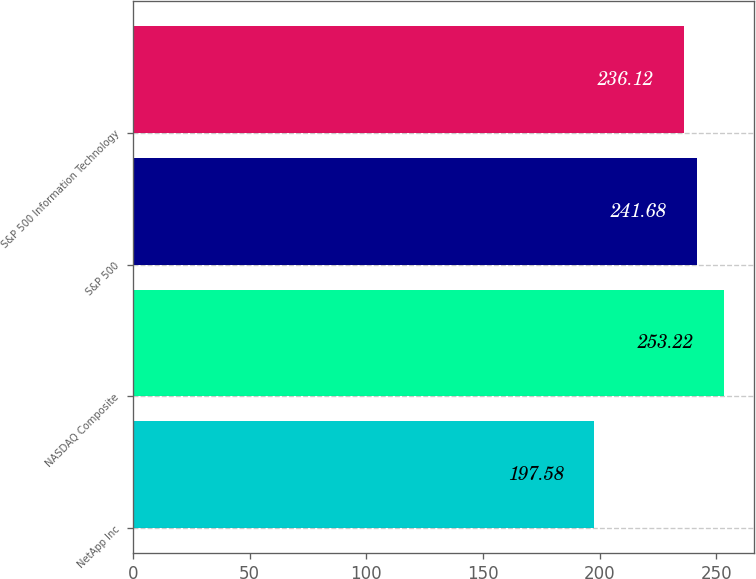<chart> <loc_0><loc_0><loc_500><loc_500><bar_chart><fcel>NetApp Inc<fcel>NASDAQ Composite<fcel>S&P 500<fcel>S&P 500 Information Technology<nl><fcel>197.58<fcel>253.22<fcel>241.68<fcel>236.12<nl></chart> 